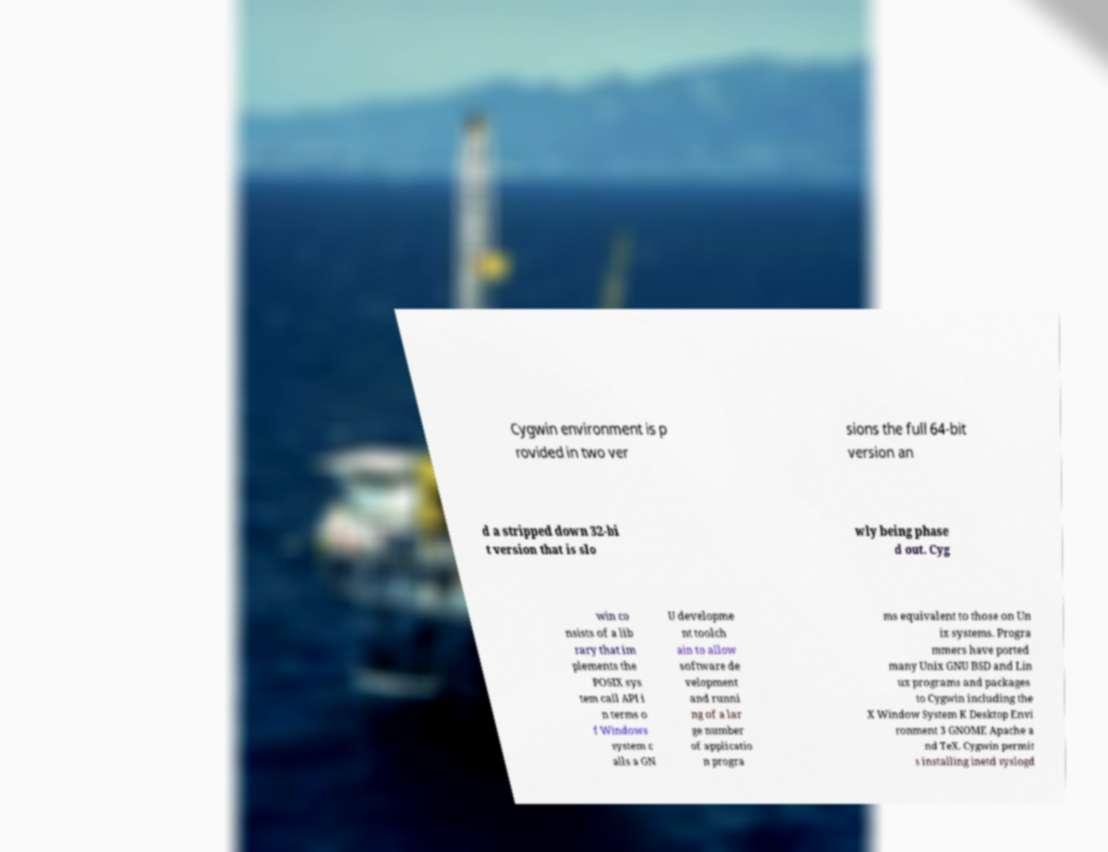Could you assist in decoding the text presented in this image and type it out clearly? Cygwin environment is p rovided in two ver sions the full 64-bit version an d a stripped down 32-bi t version that is slo wly being phase d out. Cyg win co nsists of a lib rary that im plements the POSIX sys tem call API i n terms o f Windows system c alls a GN U developme nt toolch ain to allow software de velopment and runni ng of a lar ge number of applicatio n progra ms equivalent to those on Un ix systems. Progra mmers have ported many Unix GNU BSD and Lin ux programs and packages to Cygwin including the X Window System K Desktop Envi ronment 3 GNOME Apache a nd TeX. Cygwin permit s installing inetd syslogd 